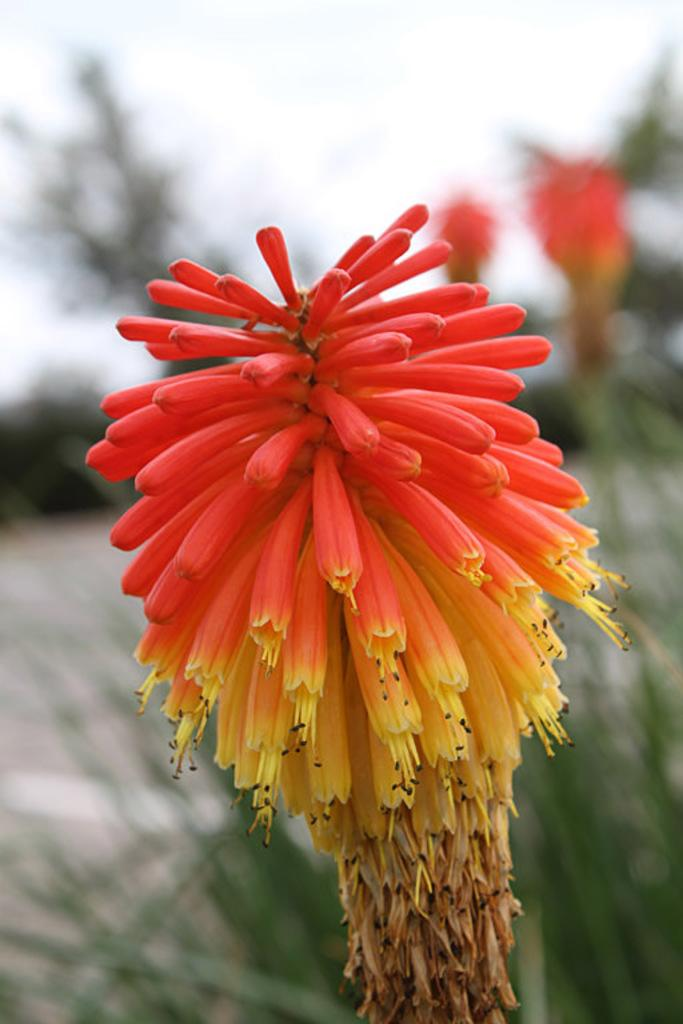What type of living organisms are in the image? There are flowers in the image. Where are the flowers located? The flowers are on plants. What colors can be seen on the flowers? The flowers have red, yellow, and brown colors. Can you describe the background of the image? The background of the image is blurred. What type of word can be seen floating in the image? There are no words present in the image; it features flowers on plants with red, yellow, and brown colors, and a blurred background. 